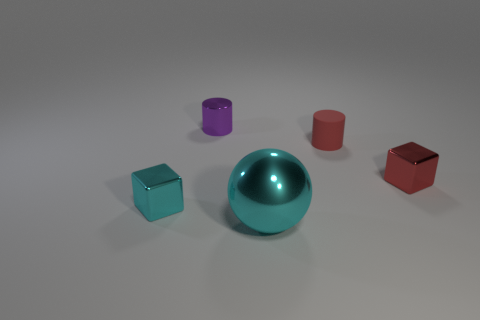Add 4 gray cylinders. How many objects exist? 9 Subtract all spheres. How many objects are left? 4 Add 4 cyan metallic objects. How many cyan metallic objects are left? 6 Add 2 tiny red shiny cylinders. How many tiny red shiny cylinders exist? 2 Subtract 1 cyan cubes. How many objects are left? 4 Subtract all red cubes. Subtract all purple shiny objects. How many objects are left? 3 